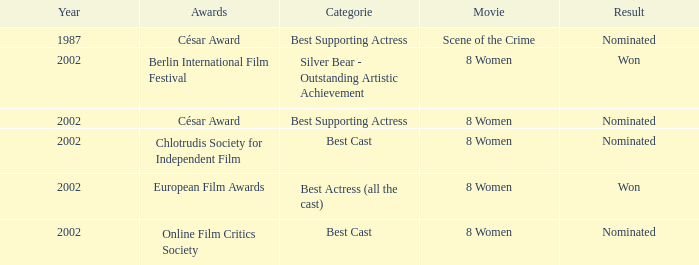At the 2002 berlin international film festival, what was the category that involved danielle darrieux? Silver Bear - Outstanding Artistic Achievement. 